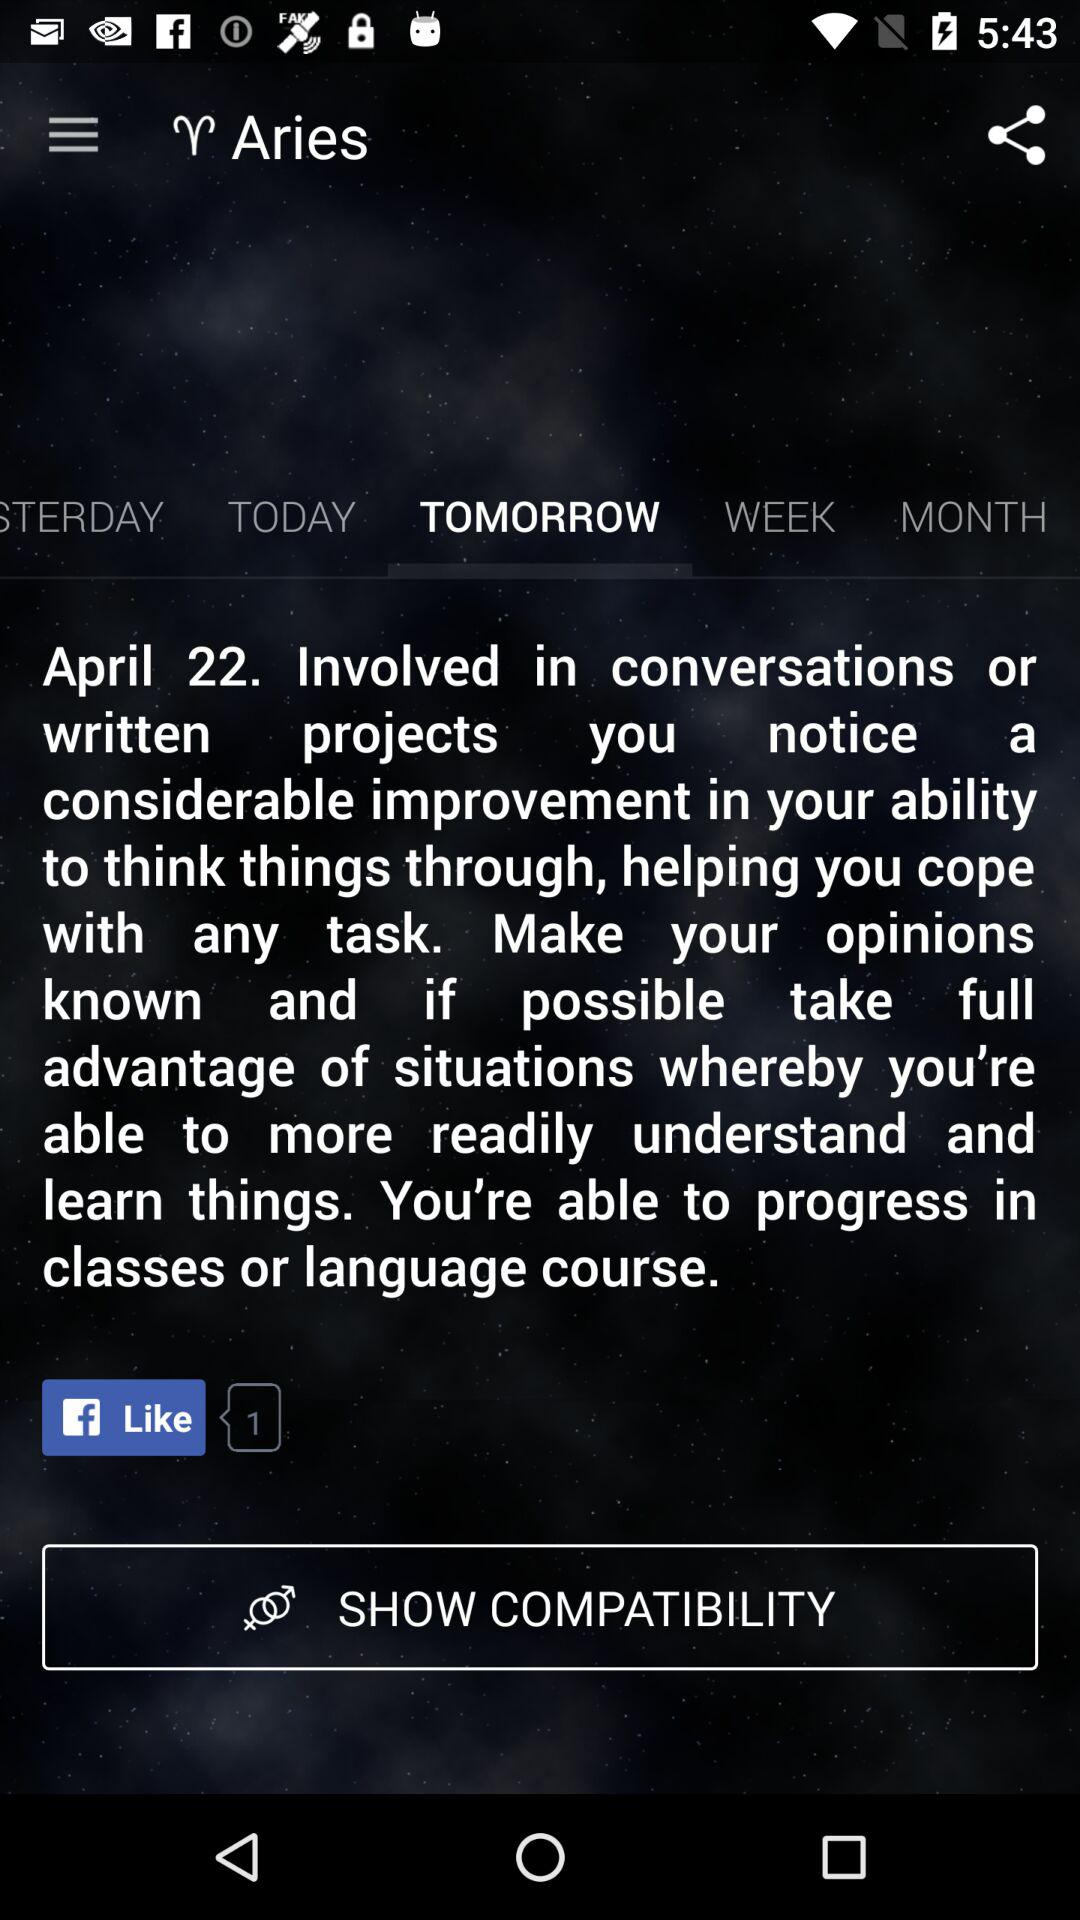What is the number of likes? The number of likes is 1. 